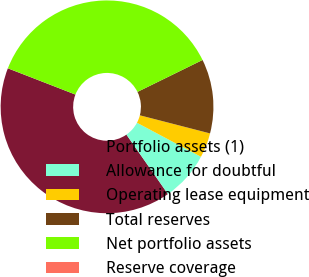Convert chart. <chart><loc_0><loc_0><loc_500><loc_500><pie_chart><fcel>Portfolio assets (1)<fcel>Allowance for doubtful<fcel>Operating lease equipment<fcel>Total reserves<fcel>Net portfolio assets<fcel>Reserve coverage<nl><fcel>40.6%<fcel>7.52%<fcel>3.76%<fcel>11.28%<fcel>36.84%<fcel>0.01%<nl></chart> 